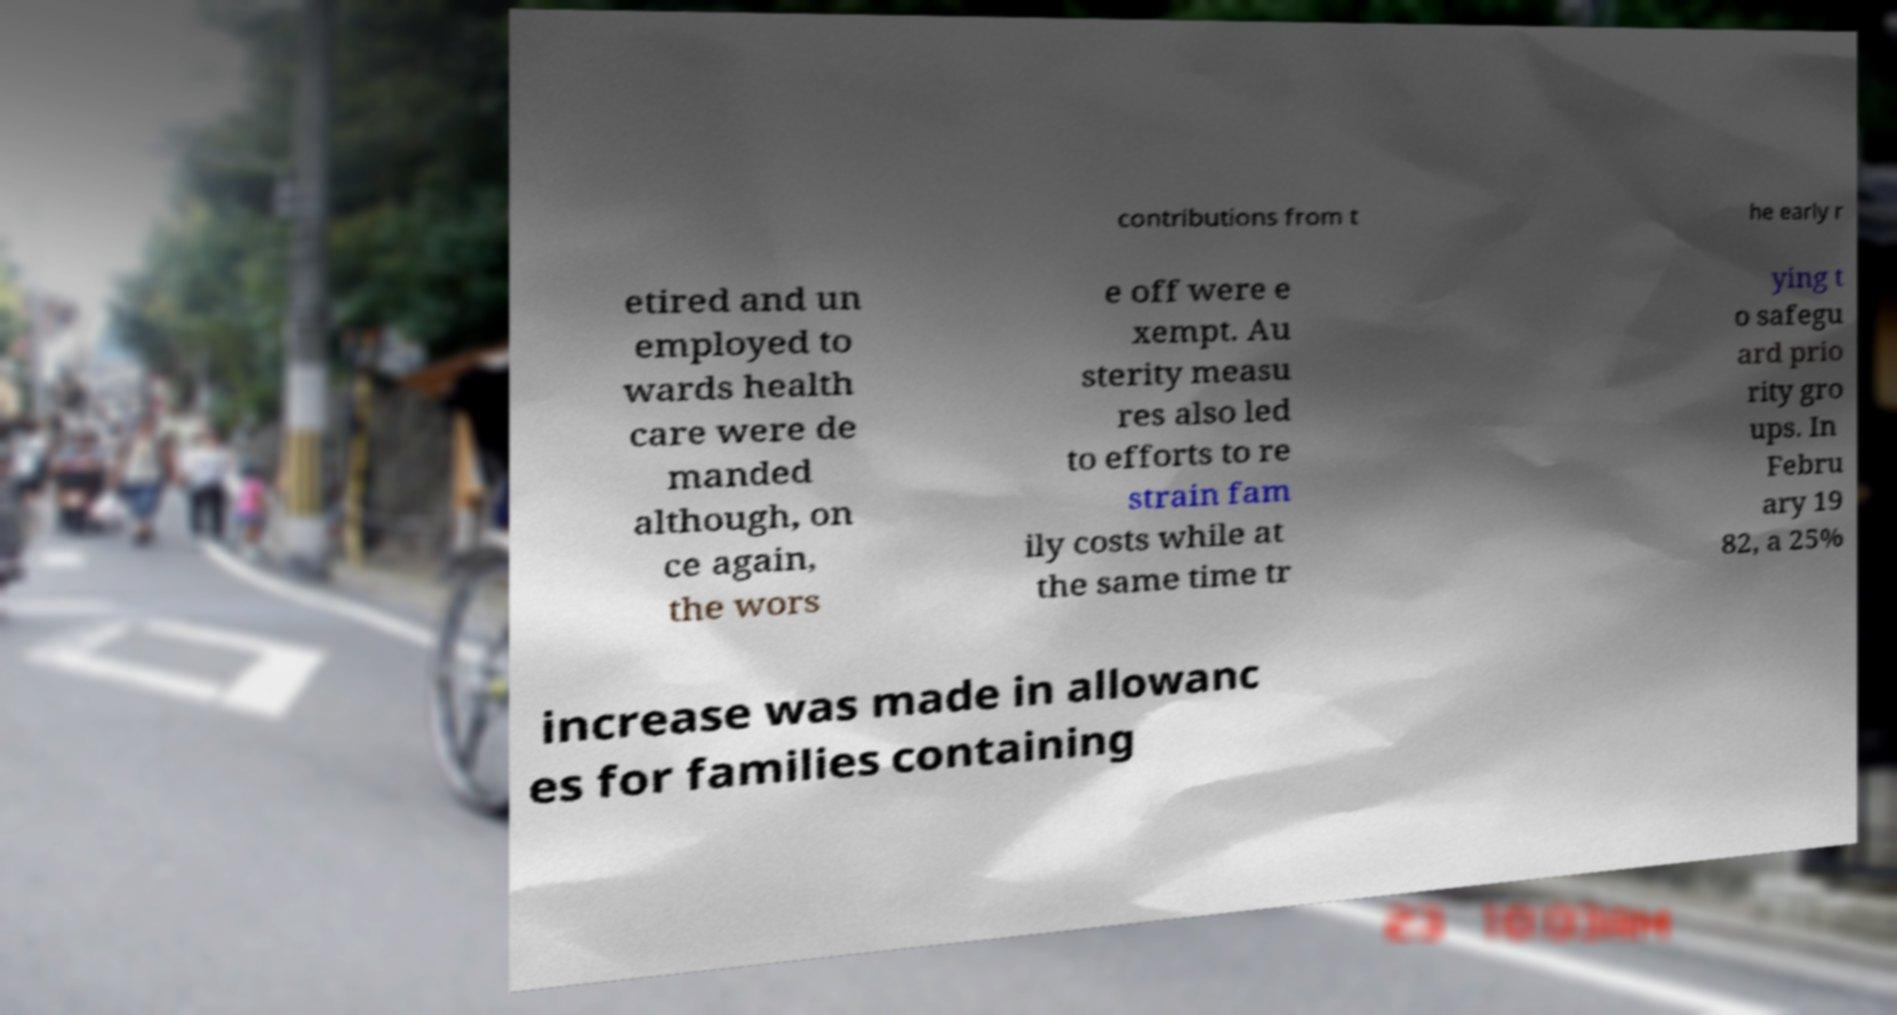There's text embedded in this image that I need extracted. Can you transcribe it verbatim? contributions from t he early r etired and un employed to wards health care were de manded although, on ce again, the wors e off were e xempt. Au sterity measu res also led to efforts to re strain fam ily costs while at the same time tr ying t o safegu ard prio rity gro ups. In Febru ary 19 82, a 25% increase was made in allowanc es for families containing 